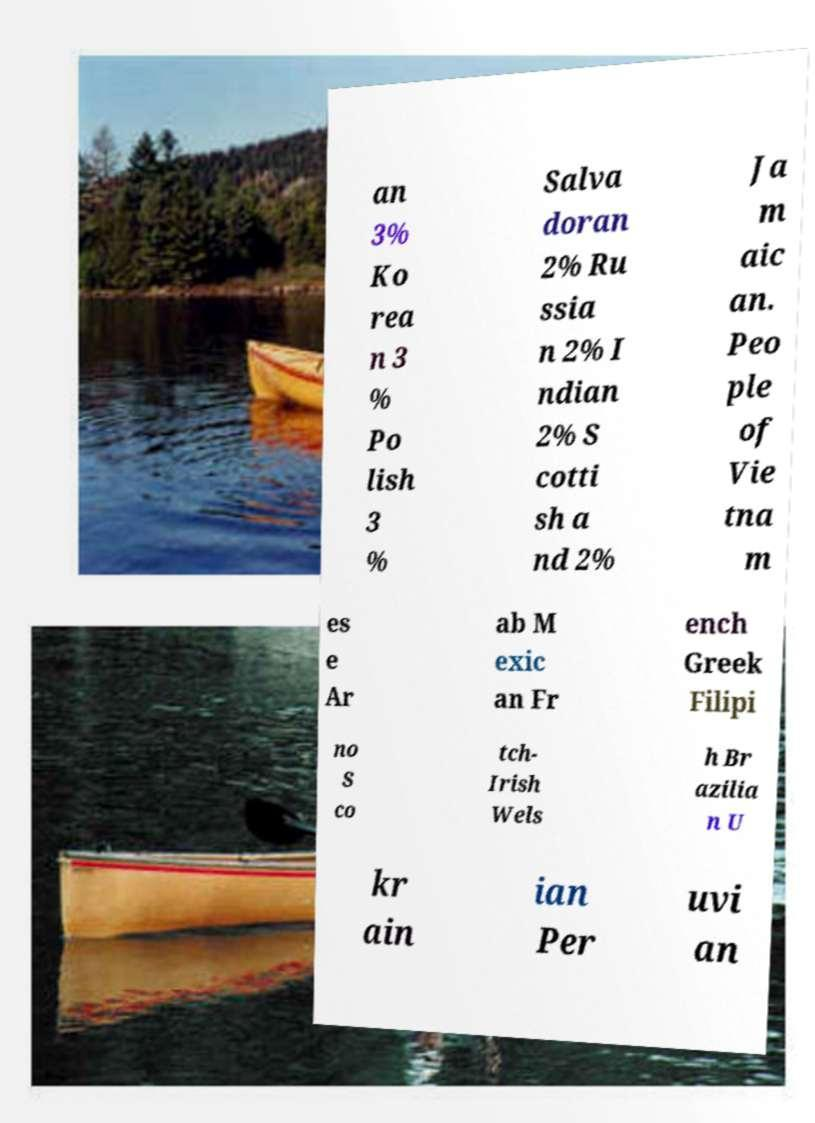Could you extract and type out the text from this image? an 3% Ko rea n 3 % Po lish 3 % Salva doran 2% Ru ssia n 2% I ndian 2% S cotti sh a nd 2% Ja m aic an. Peo ple of Vie tna m es e Ar ab M exic an Fr ench Greek Filipi no S co tch- Irish Wels h Br azilia n U kr ain ian Per uvi an 